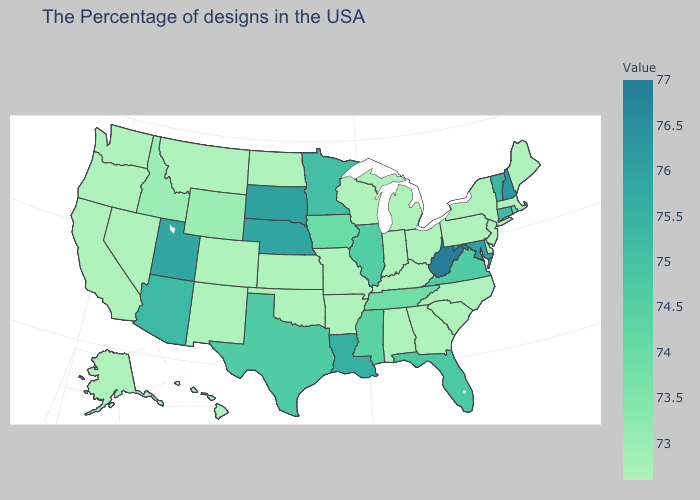Which states have the lowest value in the USA?
Quick response, please. Maine, Massachusetts, New York, New Jersey, Delaware, Pennsylvania, North Carolina, South Carolina, Ohio, Georgia, Michigan, Kentucky, Indiana, Alabama, Wisconsin, Missouri, Arkansas, Kansas, Oklahoma, North Dakota, Colorado, New Mexico, Montana, Nevada, California, Washington, Oregon, Alaska, Hawaii. Which states have the lowest value in the USA?
Concise answer only. Maine, Massachusetts, New York, New Jersey, Delaware, Pennsylvania, North Carolina, South Carolina, Ohio, Georgia, Michigan, Kentucky, Indiana, Alabama, Wisconsin, Missouri, Arkansas, Kansas, Oklahoma, North Dakota, Colorado, New Mexico, Montana, Nevada, California, Washington, Oregon, Alaska, Hawaii. Does West Virginia have the highest value in the USA?
Quick response, please. Yes. 